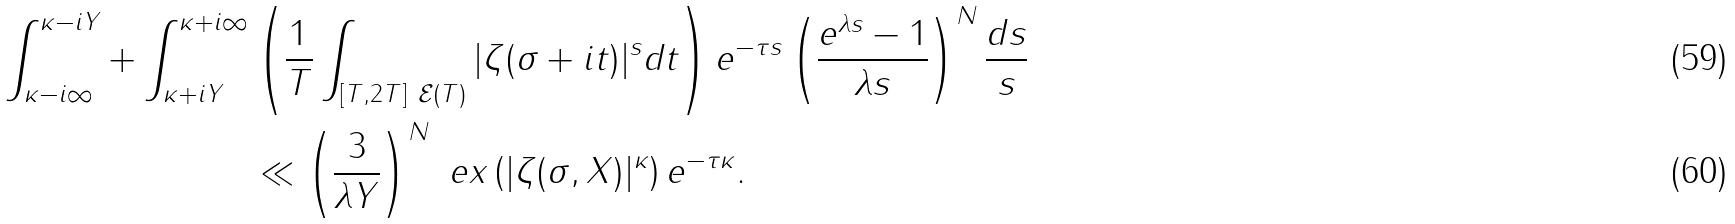Convert formula to latex. <formula><loc_0><loc_0><loc_500><loc_500>\int _ { \kappa - i \infty } ^ { \kappa - i Y } + \int _ { \kappa + i Y } ^ { \kappa + i \infty } & \left ( \frac { 1 } { T } \int _ { [ T , 2 T ] \ \mathcal { E } ( T ) } | \zeta ( \sigma + i t ) | ^ { s } d t \right ) e ^ { - \tau s } \left ( \frac { e ^ { \lambda s } - 1 } { \lambda s } \right ) ^ { N } \frac { d s } { s } \\ & \ll \left ( \frac { 3 } { \lambda Y } \right ) ^ { N } \ e x \left ( | \zeta ( \sigma , X ) | ^ { \kappa } \right ) e ^ { - \tau \kappa } .</formula> 